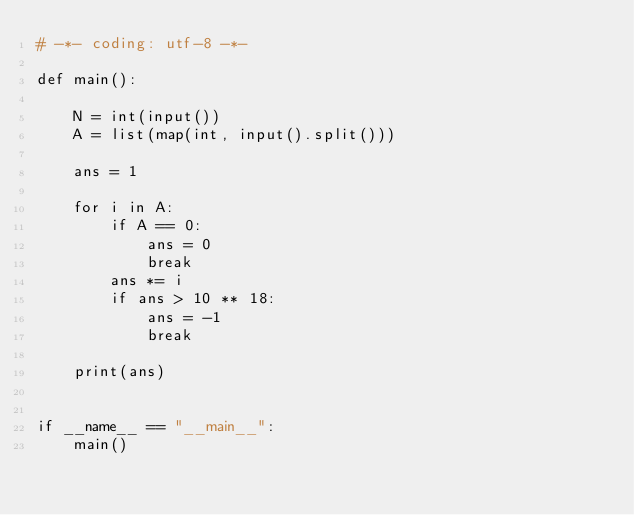Convert code to text. <code><loc_0><loc_0><loc_500><loc_500><_Python_># -*- coding: utf-8 -*-

def main():

    N = int(input())
    A = list(map(int, input().split()))

    ans = 1

    for i in A:
        if A == 0:
            ans = 0
            break
        ans *= i
        if ans > 10 ** 18:
            ans = -1
            break

    print(ans)


if __name__ == "__main__":
    main()</code> 